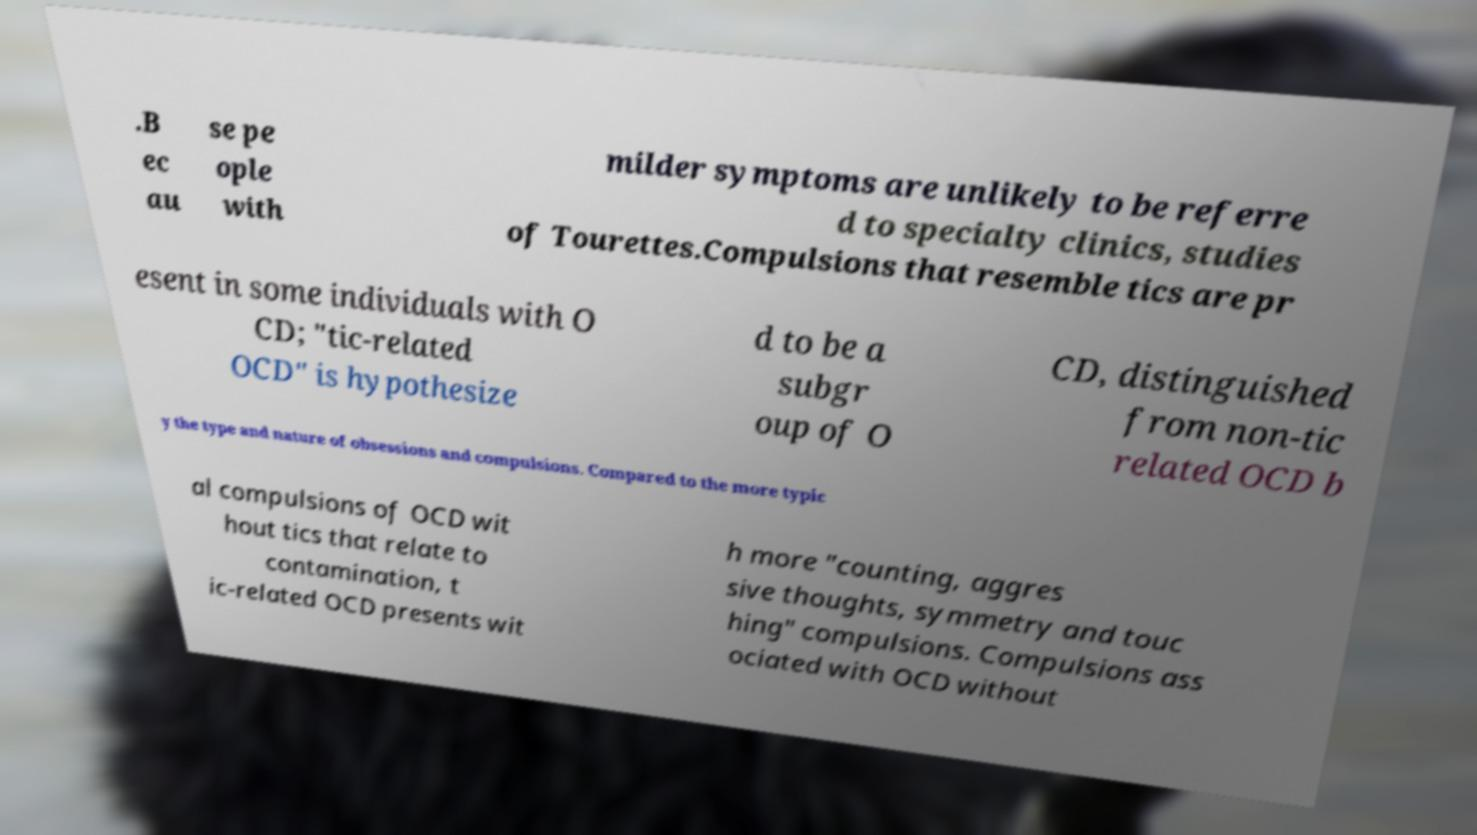There's text embedded in this image that I need extracted. Can you transcribe it verbatim? .B ec au se pe ople with milder symptoms are unlikely to be referre d to specialty clinics, studies of Tourettes.Compulsions that resemble tics are pr esent in some individuals with O CD; "tic-related OCD" is hypothesize d to be a subgr oup of O CD, distinguished from non-tic related OCD b y the type and nature of obsessions and compulsions. Compared to the more typic al compulsions of OCD wit hout tics that relate to contamination, t ic-related OCD presents wit h more "counting, aggres sive thoughts, symmetry and touc hing" compulsions. Compulsions ass ociated with OCD without 